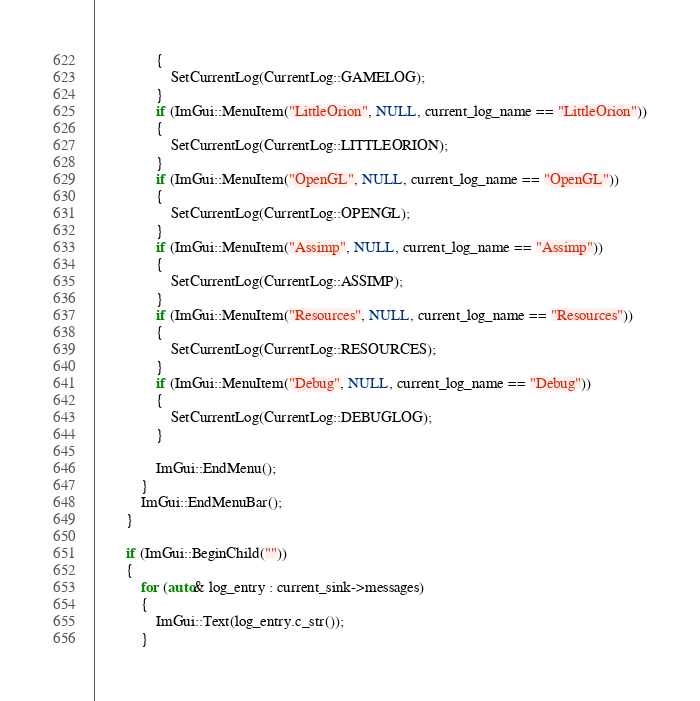Convert code to text. <code><loc_0><loc_0><loc_500><loc_500><_C++_>				{
					SetCurrentLog(CurrentLog::GAMELOG);
				}
				if (ImGui::MenuItem("LittleOrion", NULL, current_log_name == "LittleOrion"))
				{
					SetCurrentLog(CurrentLog::LITTLEORION);
				}
				if (ImGui::MenuItem("OpenGL", NULL, current_log_name == "OpenGL"))
				{
					SetCurrentLog(CurrentLog::OPENGL);
				}
				if (ImGui::MenuItem("Assimp", NULL, current_log_name == "Assimp"))
				{
					SetCurrentLog(CurrentLog::ASSIMP);
				}
				if (ImGui::MenuItem("Resources", NULL, current_log_name == "Resources"))
				{
					SetCurrentLog(CurrentLog::RESOURCES);
				}
				if (ImGui::MenuItem("Debug", NULL, current_log_name == "Debug"))
				{
					SetCurrentLog(CurrentLog::DEBUGLOG);
				}

				ImGui::EndMenu();
			}
			ImGui::EndMenuBar();
		}

		if (ImGui::BeginChild(""))
		{
			for (auto& log_entry : current_sink->messages)
			{
				ImGui::Text(log_entry.c_str());
			}</code> 